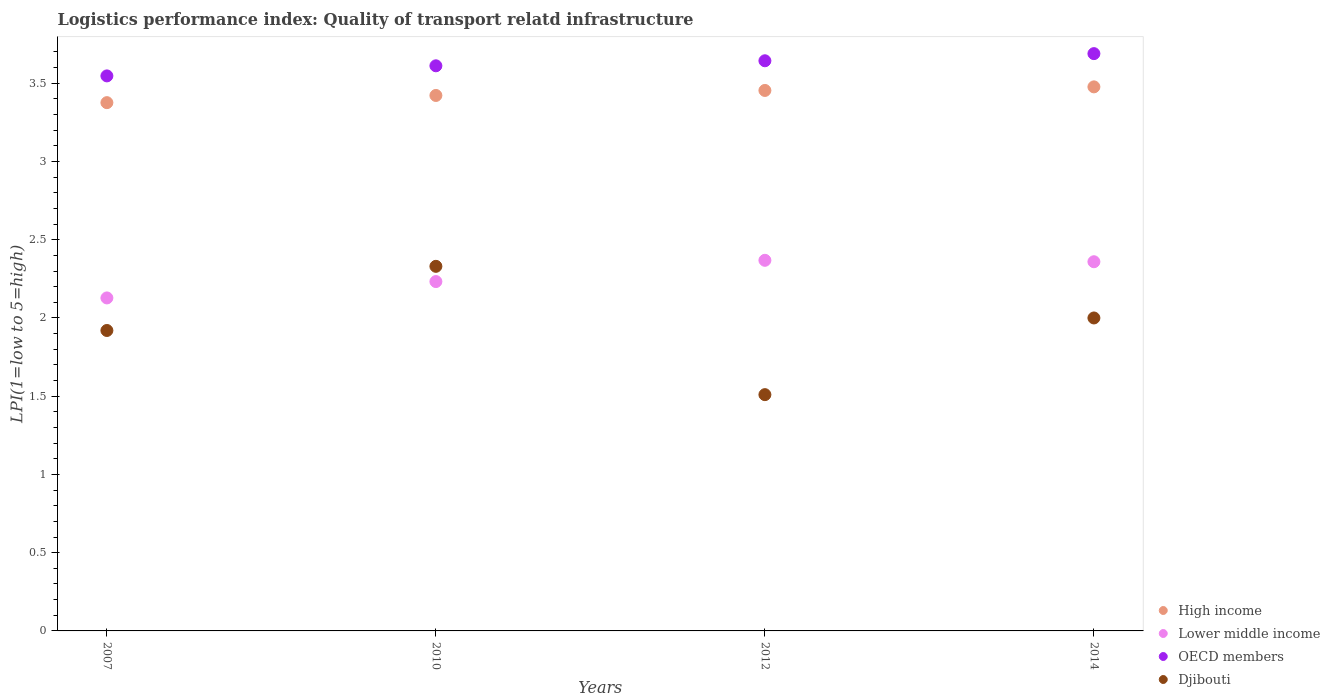What is the logistics performance index in OECD members in 2010?
Make the answer very short. 3.61. Across all years, what is the maximum logistics performance index in High income?
Give a very brief answer. 3.48. Across all years, what is the minimum logistics performance index in Lower middle income?
Your answer should be compact. 2.13. What is the total logistics performance index in Lower middle income in the graph?
Your answer should be compact. 9.09. What is the difference between the logistics performance index in Lower middle income in 2007 and that in 2014?
Provide a succinct answer. -0.23. What is the difference between the logistics performance index in Djibouti in 2014 and the logistics performance index in High income in 2010?
Make the answer very short. -1.42. What is the average logistics performance index in High income per year?
Your response must be concise. 3.43. In the year 2012, what is the difference between the logistics performance index in OECD members and logistics performance index in Djibouti?
Offer a terse response. 2.13. In how many years, is the logistics performance index in OECD members greater than 0.2?
Make the answer very short. 4. What is the ratio of the logistics performance index in Djibouti in 2010 to that in 2012?
Make the answer very short. 1.54. What is the difference between the highest and the second highest logistics performance index in Lower middle income?
Provide a succinct answer. 0.01. What is the difference between the highest and the lowest logistics performance index in Djibouti?
Make the answer very short. 0.82. Is the sum of the logistics performance index in High income in 2010 and 2014 greater than the maximum logistics performance index in Djibouti across all years?
Provide a short and direct response. Yes. Does the logistics performance index in Lower middle income monotonically increase over the years?
Your answer should be very brief. No. Is the logistics performance index in Djibouti strictly less than the logistics performance index in OECD members over the years?
Offer a terse response. Yes. How many dotlines are there?
Your answer should be compact. 4. How many years are there in the graph?
Your response must be concise. 4. What is the difference between two consecutive major ticks on the Y-axis?
Give a very brief answer. 0.5. Does the graph contain any zero values?
Make the answer very short. No. Does the graph contain grids?
Offer a terse response. No. How many legend labels are there?
Offer a terse response. 4. What is the title of the graph?
Provide a succinct answer. Logistics performance index: Quality of transport relatd infrastructure. What is the label or title of the Y-axis?
Give a very brief answer. LPI(1=low to 5=high). What is the LPI(1=low to 5=high) in High income in 2007?
Provide a short and direct response. 3.38. What is the LPI(1=low to 5=high) in Lower middle income in 2007?
Make the answer very short. 2.13. What is the LPI(1=low to 5=high) in OECD members in 2007?
Offer a terse response. 3.55. What is the LPI(1=low to 5=high) of Djibouti in 2007?
Offer a terse response. 1.92. What is the LPI(1=low to 5=high) in High income in 2010?
Provide a succinct answer. 3.42. What is the LPI(1=low to 5=high) in Lower middle income in 2010?
Keep it short and to the point. 2.23. What is the LPI(1=low to 5=high) in OECD members in 2010?
Your answer should be compact. 3.61. What is the LPI(1=low to 5=high) in Djibouti in 2010?
Give a very brief answer. 2.33. What is the LPI(1=low to 5=high) of High income in 2012?
Provide a short and direct response. 3.45. What is the LPI(1=low to 5=high) of Lower middle income in 2012?
Give a very brief answer. 2.37. What is the LPI(1=low to 5=high) of OECD members in 2012?
Your response must be concise. 3.64. What is the LPI(1=low to 5=high) of Djibouti in 2012?
Provide a short and direct response. 1.51. What is the LPI(1=low to 5=high) in High income in 2014?
Give a very brief answer. 3.48. What is the LPI(1=low to 5=high) in Lower middle income in 2014?
Your response must be concise. 2.36. What is the LPI(1=low to 5=high) of OECD members in 2014?
Offer a terse response. 3.69. What is the LPI(1=low to 5=high) in Djibouti in 2014?
Offer a terse response. 2. Across all years, what is the maximum LPI(1=low to 5=high) of High income?
Offer a very short reply. 3.48. Across all years, what is the maximum LPI(1=low to 5=high) of Lower middle income?
Your answer should be very brief. 2.37. Across all years, what is the maximum LPI(1=low to 5=high) in OECD members?
Offer a terse response. 3.69. Across all years, what is the maximum LPI(1=low to 5=high) in Djibouti?
Provide a succinct answer. 2.33. Across all years, what is the minimum LPI(1=low to 5=high) in High income?
Ensure brevity in your answer.  3.38. Across all years, what is the minimum LPI(1=low to 5=high) in Lower middle income?
Offer a terse response. 2.13. Across all years, what is the minimum LPI(1=low to 5=high) in OECD members?
Keep it short and to the point. 3.55. Across all years, what is the minimum LPI(1=low to 5=high) of Djibouti?
Make the answer very short. 1.51. What is the total LPI(1=low to 5=high) of High income in the graph?
Make the answer very short. 13.73. What is the total LPI(1=low to 5=high) of Lower middle income in the graph?
Provide a short and direct response. 9.09. What is the total LPI(1=low to 5=high) in OECD members in the graph?
Offer a very short reply. 14.49. What is the total LPI(1=low to 5=high) of Djibouti in the graph?
Give a very brief answer. 7.76. What is the difference between the LPI(1=low to 5=high) of High income in 2007 and that in 2010?
Offer a very short reply. -0.05. What is the difference between the LPI(1=low to 5=high) of Lower middle income in 2007 and that in 2010?
Your answer should be compact. -0.1. What is the difference between the LPI(1=low to 5=high) in OECD members in 2007 and that in 2010?
Give a very brief answer. -0.06. What is the difference between the LPI(1=low to 5=high) in Djibouti in 2007 and that in 2010?
Your answer should be very brief. -0.41. What is the difference between the LPI(1=low to 5=high) of High income in 2007 and that in 2012?
Provide a succinct answer. -0.08. What is the difference between the LPI(1=low to 5=high) in Lower middle income in 2007 and that in 2012?
Provide a short and direct response. -0.24. What is the difference between the LPI(1=low to 5=high) of OECD members in 2007 and that in 2012?
Provide a succinct answer. -0.1. What is the difference between the LPI(1=low to 5=high) in Djibouti in 2007 and that in 2012?
Your answer should be very brief. 0.41. What is the difference between the LPI(1=low to 5=high) of High income in 2007 and that in 2014?
Keep it short and to the point. -0.1. What is the difference between the LPI(1=low to 5=high) in Lower middle income in 2007 and that in 2014?
Your answer should be very brief. -0.23. What is the difference between the LPI(1=low to 5=high) of OECD members in 2007 and that in 2014?
Provide a short and direct response. -0.14. What is the difference between the LPI(1=low to 5=high) of Djibouti in 2007 and that in 2014?
Make the answer very short. -0.08. What is the difference between the LPI(1=low to 5=high) of High income in 2010 and that in 2012?
Offer a very short reply. -0.03. What is the difference between the LPI(1=low to 5=high) in Lower middle income in 2010 and that in 2012?
Give a very brief answer. -0.14. What is the difference between the LPI(1=low to 5=high) of OECD members in 2010 and that in 2012?
Provide a short and direct response. -0.03. What is the difference between the LPI(1=low to 5=high) in Djibouti in 2010 and that in 2012?
Keep it short and to the point. 0.82. What is the difference between the LPI(1=low to 5=high) of High income in 2010 and that in 2014?
Your response must be concise. -0.05. What is the difference between the LPI(1=low to 5=high) in Lower middle income in 2010 and that in 2014?
Provide a succinct answer. -0.13. What is the difference between the LPI(1=low to 5=high) of OECD members in 2010 and that in 2014?
Give a very brief answer. -0.08. What is the difference between the LPI(1=low to 5=high) of Djibouti in 2010 and that in 2014?
Provide a short and direct response. 0.33. What is the difference between the LPI(1=low to 5=high) of High income in 2012 and that in 2014?
Your answer should be compact. -0.02. What is the difference between the LPI(1=low to 5=high) of Lower middle income in 2012 and that in 2014?
Make the answer very short. 0.01. What is the difference between the LPI(1=low to 5=high) of OECD members in 2012 and that in 2014?
Offer a terse response. -0.05. What is the difference between the LPI(1=low to 5=high) of Djibouti in 2012 and that in 2014?
Your answer should be compact. -0.49. What is the difference between the LPI(1=low to 5=high) of High income in 2007 and the LPI(1=low to 5=high) of Lower middle income in 2010?
Ensure brevity in your answer.  1.14. What is the difference between the LPI(1=low to 5=high) of High income in 2007 and the LPI(1=low to 5=high) of OECD members in 2010?
Keep it short and to the point. -0.24. What is the difference between the LPI(1=low to 5=high) in High income in 2007 and the LPI(1=low to 5=high) in Djibouti in 2010?
Provide a succinct answer. 1.05. What is the difference between the LPI(1=low to 5=high) of Lower middle income in 2007 and the LPI(1=low to 5=high) of OECD members in 2010?
Offer a very short reply. -1.48. What is the difference between the LPI(1=low to 5=high) of Lower middle income in 2007 and the LPI(1=low to 5=high) of Djibouti in 2010?
Keep it short and to the point. -0.2. What is the difference between the LPI(1=low to 5=high) in OECD members in 2007 and the LPI(1=low to 5=high) in Djibouti in 2010?
Your answer should be compact. 1.22. What is the difference between the LPI(1=low to 5=high) in High income in 2007 and the LPI(1=low to 5=high) in Lower middle income in 2012?
Offer a terse response. 1.01. What is the difference between the LPI(1=low to 5=high) in High income in 2007 and the LPI(1=low to 5=high) in OECD members in 2012?
Provide a short and direct response. -0.27. What is the difference between the LPI(1=low to 5=high) in High income in 2007 and the LPI(1=low to 5=high) in Djibouti in 2012?
Keep it short and to the point. 1.87. What is the difference between the LPI(1=low to 5=high) in Lower middle income in 2007 and the LPI(1=low to 5=high) in OECD members in 2012?
Ensure brevity in your answer.  -1.52. What is the difference between the LPI(1=low to 5=high) of Lower middle income in 2007 and the LPI(1=low to 5=high) of Djibouti in 2012?
Make the answer very short. 0.62. What is the difference between the LPI(1=low to 5=high) of OECD members in 2007 and the LPI(1=low to 5=high) of Djibouti in 2012?
Offer a very short reply. 2.04. What is the difference between the LPI(1=low to 5=high) in High income in 2007 and the LPI(1=low to 5=high) in Lower middle income in 2014?
Offer a very short reply. 1.02. What is the difference between the LPI(1=low to 5=high) in High income in 2007 and the LPI(1=low to 5=high) in OECD members in 2014?
Make the answer very short. -0.31. What is the difference between the LPI(1=low to 5=high) of High income in 2007 and the LPI(1=low to 5=high) of Djibouti in 2014?
Offer a terse response. 1.38. What is the difference between the LPI(1=low to 5=high) of Lower middle income in 2007 and the LPI(1=low to 5=high) of OECD members in 2014?
Your answer should be very brief. -1.56. What is the difference between the LPI(1=low to 5=high) of Lower middle income in 2007 and the LPI(1=low to 5=high) of Djibouti in 2014?
Your answer should be compact. 0.13. What is the difference between the LPI(1=low to 5=high) of OECD members in 2007 and the LPI(1=low to 5=high) of Djibouti in 2014?
Offer a very short reply. 1.55. What is the difference between the LPI(1=low to 5=high) of High income in 2010 and the LPI(1=low to 5=high) of Lower middle income in 2012?
Keep it short and to the point. 1.05. What is the difference between the LPI(1=low to 5=high) of High income in 2010 and the LPI(1=low to 5=high) of OECD members in 2012?
Provide a short and direct response. -0.22. What is the difference between the LPI(1=low to 5=high) of High income in 2010 and the LPI(1=low to 5=high) of Djibouti in 2012?
Provide a short and direct response. 1.91. What is the difference between the LPI(1=low to 5=high) in Lower middle income in 2010 and the LPI(1=low to 5=high) in OECD members in 2012?
Your response must be concise. -1.41. What is the difference between the LPI(1=low to 5=high) of Lower middle income in 2010 and the LPI(1=low to 5=high) of Djibouti in 2012?
Offer a very short reply. 0.72. What is the difference between the LPI(1=low to 5=high) of OECD members in 2010 and the LPI(1=low to 5=high) of Djibouti in 2012?
Provide a succinct answer. 2.1. What is the difference between the LPI(1=low to 5=high) of High income in 2010 and the LPI(1=low to 5=high) of Lower middle income in 2014?
Your answer should be compact. 1.06. What is the difference between the LPI(1=low to 5=high) of High income in 2010 and the LPI(1=low to 5=high) of OECD members in 2014?
Provide a short and direct response. -0.27. What is the difference between the LPI(1=low to 5=high) of High income in 2010 and the LPI(1=low to 5=high) of Djibouti in 2014?
Your answer should be very brief. 1.42. What is the difference between the LPI(1=low to 5=high) in Lower middle income in 2010 and the LPI(1=low to 5=high) in OECD members in 2014?
Your answer should be very brief. -1.46. What is the difference between the LPI(1=low to 5=high) in Lower middle income in 2010 and the LPI(1=low to 5=high) in Djibouti in 2014?
Ensure brevity in your answer.  0.23. What is the difference between the LPI(1=low to 5=high) in OECD members in 2010 and the LPI(1=low to 5=high) in Djibouti in 2014?
Your response must be concise. 1.61. What is the difference between the LPI(1=low to 5=high) of High income in 2012 and the LPI(1=low to 5=high) of Lower middle income in 2014?
Your response must be concise. 1.09. What is the difference between the LPI(1=low to 5=high) in High income in 2012 and the LPI(1=low to 5=high) in OECD members in 2014?
Make the answer very short. -0.24. What is the difference between the LPI(1=low to 5=high) of High income in 2012 and the LPI(1=low to 5=high) of Djibouti in 2014?
Your answer should be compact. 1.45. What is the difference between the LPI(1=low to 5=high) in Lower middle income in 2012 and the LPI(1=low to 5=high) in OECD members in 2014?
Your response must be concise. -1.32. What is the difference between the LPI(1=low to 5=high) in Lower middle income in 2012 and the LPI(1=low to 5=high) in Djibouti in 2014?
Offer a very short reply. 0.37. What is the difference between the LPI(1=low to 5=high) of OECD members in 2012 and the LPI(1=low to 5=high) of Djibouti in 2014?
Provide a succinct answer. 1.64. What is the average LPI(1=low to 5=high) of High income per year?
Ensure brevity in your answer.  3.43. What is the average LPI(1=low to 5=high) in Lower middle income per year?
Provide a short and direct response. 2.27. What is the average LPI(1=low to 5=high) in OECD members per year?
Offer a very short reply. 3.62. What is the average LPI(1=low to 5=high) of Djibouti per year?
Your answer should be very brief. 1.94. In the year 2007, what is the difference between the LPI(1=low to 5=high) of High income and LPI(1=low to 5=high) of Lower middle income?
Give a very brief answer. 1.25. In the year 2007, what is the difference between the LPI(1=low to 5=high) in High income and LPI(1=low to 5=high) in OECD members?
Ensure brevity in your answer.  -0.17. In the year 2007, what is the difference between the LPI(1=low to 5=high) in High income and LPI(1=low to 5=high) in Djibouti?
Offer a very short reply. 1.46. In the year 2007, what is the difference between the LPI(1=low to 5=high) in Lower middle income and LPI(1=low to 5=high) in OECD members?
Provide a short and direct response. -1.42. In the year 2007, what is the difference between the LPI(1=low to 5=high) of Lower middle income and LPI(1=low to 5=high) of Djibouti?
Your answer should be very brief. 0.21. In the year 2007, what is the difference between the LPI(1=low to 5=high) in OECD members and LPI(1=low to 5=high) in Djibouti?
Offer a very short reply. 1.63. In the year 2010, what is the difference between the LPI(1=low to 5=high) of High income and LPI(1=low to 5=high) of Lower middle income?
Make the answer very short. 1.19. In the year 2010, what is the difference between the LPI(1=low to 5=high) in High income and LPI(1=low to 5=high) in OECD members?
Offer a terse response. -0.19. In the year 2010, what is the difference between the LPI(1=low to 5=high) of High income and LPI(1=low to 5=high) of Djibouti?
Your response must be concise. 1.09. In the year 2010, what is the difference between the LPI(1=low to 5=high) in Lower middle income and LPI(1=low to 5=high) in OECD members?
Make the answer very short. -1.38. In the year 2010, what is the difference between the LPI(1=low to 5=high) of Lower middle income and LPI(1=low to 5=high) of Djibouti?
Give a very brief answer. -0.1. In the year 2010, what is the difference between the LPI(1=low to 5=high) of OECD members and LPI(1=low to 5=high) of Djibouti?
Give a very brief answer. 1.28. In the year 2012, what is the difference between the LPI(1=low to 5=high) of High income and LPI(1=low to 5=high) of Lower middle income?
Your answer should be compact. 1.09. In the year 2012, what is the difference between the LPI(1=low to 5=high) of High income and LPI(1=low to 5=high) of OECD members?
Make the answer very short. -0.19. In the year 2012, what is the difference between the LPI(1=low to 5=high) in High income and LPI(1=low to 5=high) in Djibouti?
Offer a terse response. 1.94. In the year 2012, what is the difference between the LPI(1=low to 5=high) in Lower middle income and LPI(1=low to 5=high) in OECD members?
Make the answer very short. -1.28. In the year 2012, what is the difference between the LPI(1=low to 5=high) in Lower middle income and LPI(1=low to 5=high) in Djibouti?
Offer a terse response. 0.86. In the year 2012, what is the difference between the LPI(1=low to 5=high) of OECD members and LPI(1=low to 5=high) of Djibouti?
Your answer should be compact. 2.13. In the year 2014, what is the difference between the LPI(1=low to 5=high) of High income and LPI(1=low to 5=high) of Lower middle income?
Offer a terse response. 1.12. In the year 2014, what is the difference between the LPI(1=low to 5=high) in High income and LPI(1=low to 5=high) in OECD members?
Ensure brevity in your answer.  -0.21. In the year 2014, what is the difference between the LPI(1=low to 5=high) of High income and LPI(1=low to 5=high) of Djibouti?
Provide a succinct answer. 1.48. In the year 2014, what is the difference between the LPI(1=low to 5=high) in Lower middle income and LPI(1=low to 5=high) in OECD members?
Give a very brief answer. -1.33. In the year 2014, what is the difference between the LPI(1=low to 5=high) of Lower middle income and LPI(1=low to 5=high) of Djibouti?
Provide a succinct answer. 0.36. In the year 2014, what is the difference between the LPI(1=low to 5=high) of OECD members and LPI(1=low to 5=high) of Djibouti?
Keep it short and to the point. 1.69. What is the ratio of the LPI(1=low to 5=high) in High income in 2007 to that in 2010?
Your answer should be compact. 0.99. What is the ratio of the LPI(1=low to 5=high) in Lower middle income in 2007 to that in 2010?
Offer a very short reply. 0.95. What is the ratio of the LPI(1=low to 5=high) in OECD members in 2007 to that in 2010?
Your answer should be compact. 0.98. What is the ratio of the LPI(1=low to 5=high) of Djibouti in 2007 to that in 2010?
Keep it short and to the point. 0.82. What is the ratio of the LPI(1=low to 5=high) of High income in 2007 to that in 2012?
Your answer should be compact. 0.98. What is the ratio of the LPI(1=low to 5=high) in Lower middle income in 2007 to that in 2012?
Provide a succinct answer. 0.9. What is the ratio of the LPI(1=low to 5=high) of OECD members in 2007 to that in 2012?
Provide a short and direct response. 0.97. What is the ratio of the LPI(1=low to 5=high) in Djibouti in 2007 to that in 2012?
Make the answer very short. 1.27. What is the ratio of the LPI(1=low to 5=high) in High income in 2007 to that in 2014?
Give a very brief answer. 0.97. What is the ratio of the LPI(1=low to 5=high) in Lower middle income in 2007 to that in 2014?
Make the answer very short. 0.9. What is the ratio of the LPI(1=low to 5=high) in OECD members in 2007 to that in 2014?
Provide a short and direct response. 0.96. What is the ratio of the LPI(1=low to 5=high) in Djibouti in 2007 to that in 2014?
Your answer should be compact. 0.96. What is the ratio of the LPI(1=low to 5=high) of High income in 2010 to that in 2012?
Offer a very short reply. 0.99. What is the ratio of the LPI(1=low to 5=high) in Lower middle income in 2010 to that in 2012?
Provide a short and direct response. 0.94. What is the ratio of the LPI(1=low to 5=high) in Djibouti in 2010 to that in 2012?
Provide a succinct answer. 1.54. What is the ratio of the LPI(1=low to 5=high) of High income in 2010 to that in 2014?
Provide a succinct answer. 0.98. What is the ratio of the LPI(1=low to 5=high) in Lower middle income in 2010 to that in 2014?
Offer a very short reply. 0.95. What is the ratio of the LPI(1=low to 5=high) in OECD members in 2010 to that in 2014?
Your answer should be compact. 0.98. What is the ratio of the LPI(1=low to 5=high) in Djibouti in 2010 to that in 2014?
Give a very brief answer. 1.17. What is the ratio of the LPI(1=low to 5=high) in High income in 2012 to that in 2014?
Provide a short and direct response. 0.99. What is the ratio of the LPI(1=low to 5=high) in Lower middle income in 2012 to that in 2014?
Your answer should be very brief. 1. What is the ratio of the LPI(1=low to 5=high) of OECD members in 2012 to that in 2014?
Ensure brevity in your answer.  0.99. What is the ratio of the LPI(1=low to 5=high) of Djibouti in 2012 to that in 2014?
Make the answer very short. 0.76. What is the difference between the highest and the second highest LPI(1=low to 5=high) of High income?
Your answer should be very brief. 0.02. What is the difference between the highest and the second highest LPI(1=low to 5=high) of Lower middle income?
Make the answer very short. 0.01. What is the difference between the highest and the second highest LPI(1=low to 5=high) of OECD members?
Provide a short and direct response. 0.05. What is the difference between the highest and the second highest LPI(1=low to 5=high) in Djibouti?
Keep it short and to the point. 0.33. What is the difference between the highest and the lowest LPI(1=low to 5=high) of High income?
Give a very brief answer. 0.1. What is the difference between the highest and the lowest LPI(1=low to 5=high) of Lower middle income?
Make the answer very short. 0.24. What is the difference between the highest and the lowest LPI(1=low to 5=high) in OECD members?
Give a very brief answer. 0.14. What is the difference between the highest and the lowest LPI(1=low to 5=high) in Djibouti?
Make the answer very short. 0.82. 